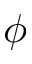<formula> <loc_0><loc_0><loc_500><loc_500>\phi</formula> 